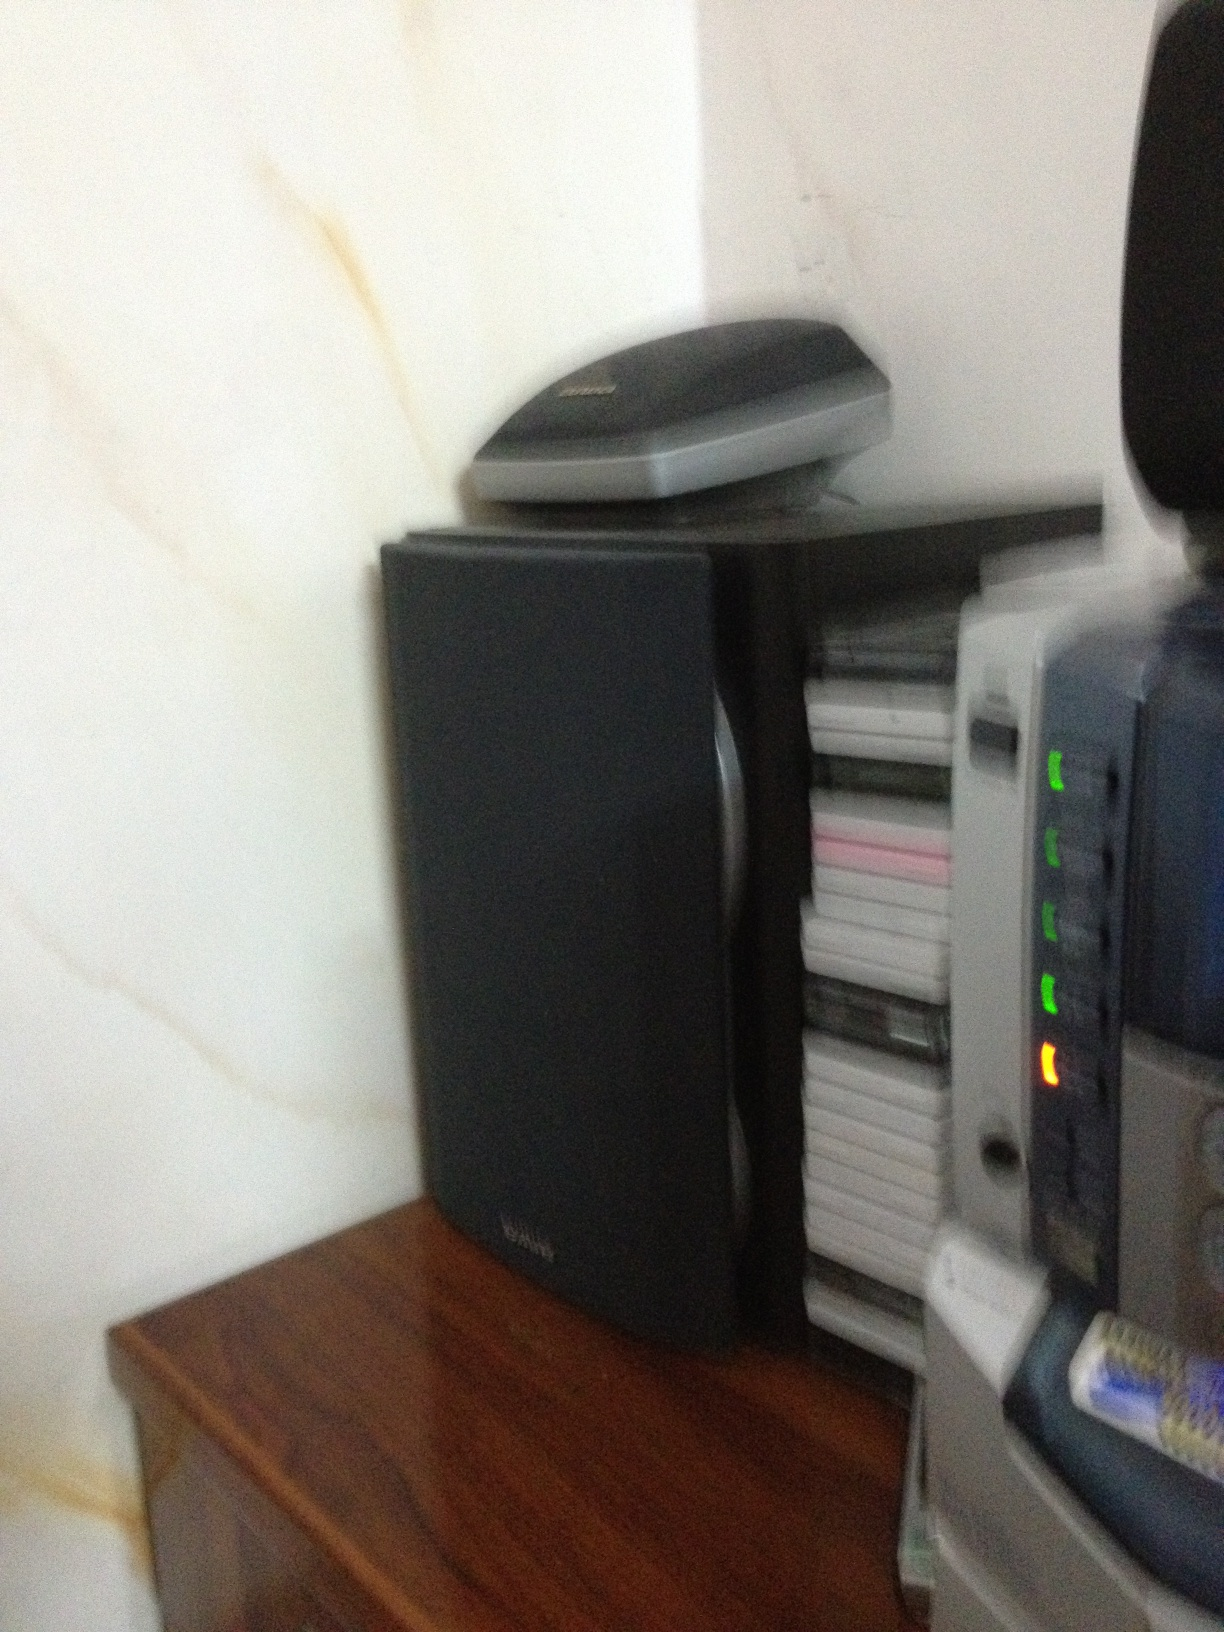How could this space be arranged more efficiently? To arrange this space more efficiently, consider the following changes: 
1. Consolidate cables and place them out of sight to reduce clutter. 
2. Stack the media (CDs or DVDs) in a dedicated storage unit that allows easy access while conserving space. 
3. Position the speaker in a way that optimizes sound output, perhaps using speaker stands or wall mounts. 
4. If the scanner is frequently used, ensure it is at a convenient height and angle for quick access. Otherwise, store it in a designated drawer when not in use. 
5. Re-configure the arrangement to keep the commonly used devices more accessible and the less frequently used items either stored away or positioned in a less obtrusive manner. 